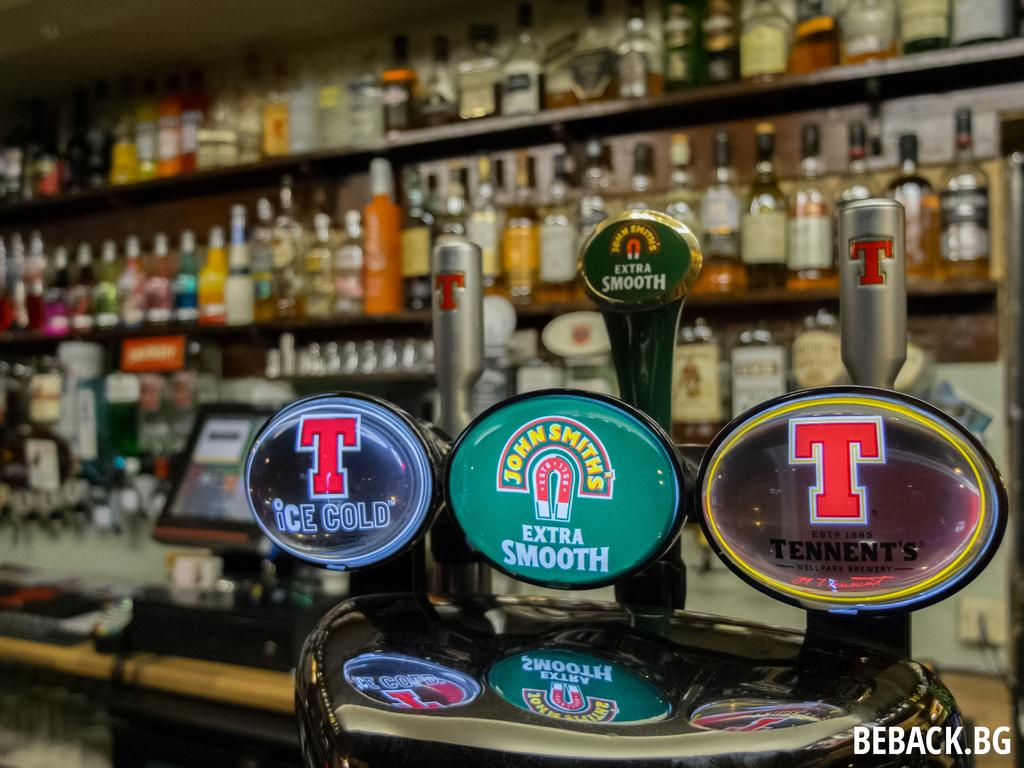<image>
Give a short and clear explanation of the subsequent image. beback.bg  is sponsoring a liquor store, with shelves full of different alcohol and beer taps. 